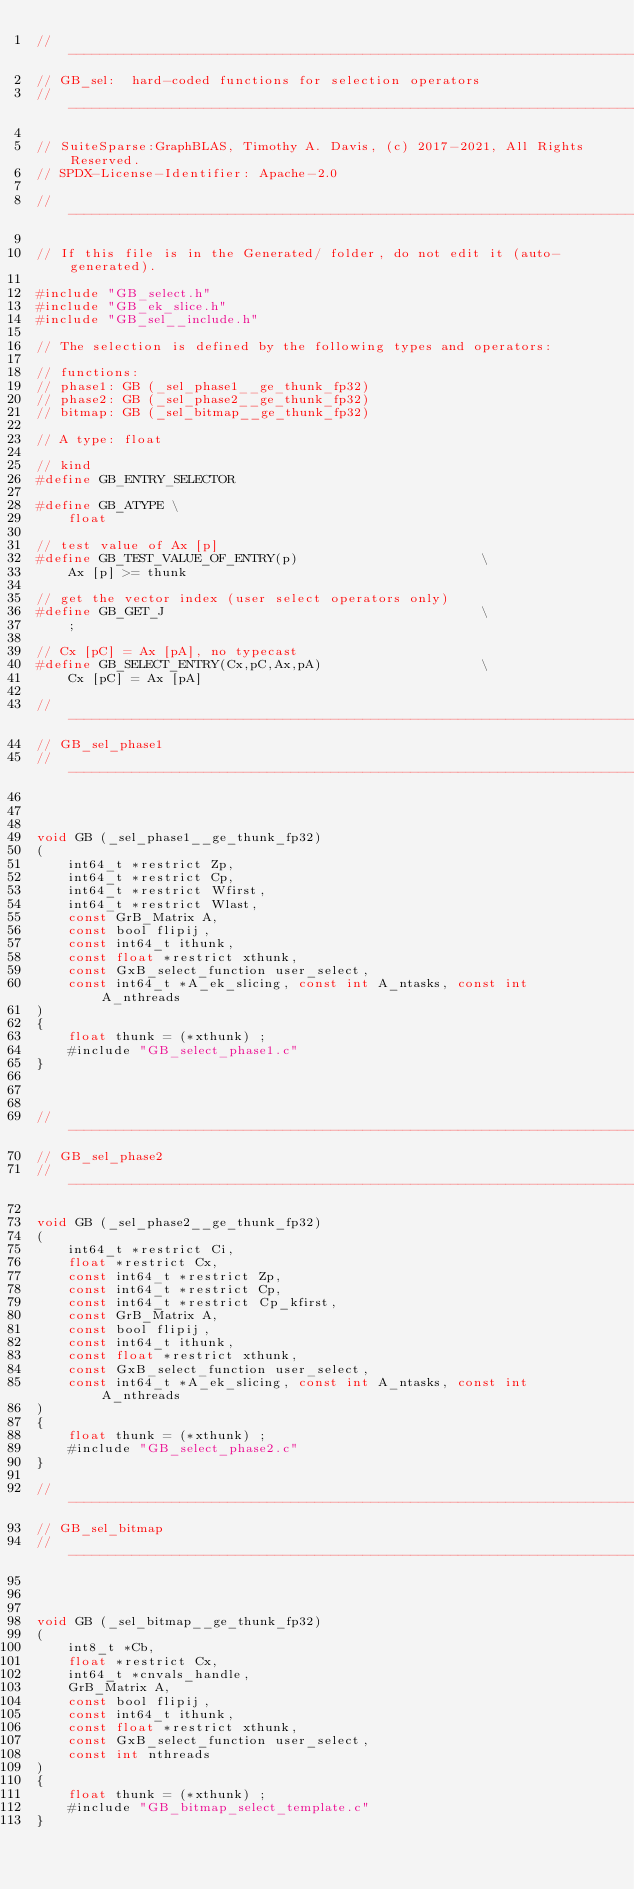Convert code to text. <code><loc_0><loc_0><loc_500><loc_500><_C_>//------------------------------------------------------------------------------
// GB_sel:  hard-coded functions for selection operators
//------------------------------------------------------------------------------

// SuiteSparse:GraphBLAS, Timothy A. Davis, (c) 2017-2021, All Rights Reserved.
// SPDX-License-Identifier: Apache-2.0

//------------------------------------------------------------------------------

// If this file is in the Generated/ folder, do not edit it (auto-generated).

#include "GB_select.h"
#include "GB_ek_slice.h"
#include "GB_sel__include.h"

// The selection is defined by the following types and operators:

// functions:
// phase1: GB (_sel_phase1__ge_thunk_fp32)
// phase2: GB (_sel_phase2__ge_thunk_fp32)
// bitmap: GB (_sel_bitmap__ge_thunk_fp32)

// A type: float

// kind
#define GB_ENTRY_SELECTOR

#define GB_ATYPE \
    float

// test value of Ax [p]
#define GB_TEST_VALUE_OF_ENTRY(p)                       \
    Ax [p] >= thunk

// get the vector index (user select operators only)
#define GB_GET_J                                        \
    ;

// Cx [pC] = Ax [pA], no typecast
#define GB_SELECT_ENTRY(Cx,pC,Ax,pA)                    \
    Cx [pC] = Ax [pA]

//------------------------------------------------------------------------------
// GB_sel_phase1
//------------------------------------------------------------------------------



void GB (_sel_phase1__ge_thunk_fp32)
(
    int64_t *restrict Zp,
    int64_t *restrict Cp,
    int64_t *restrict Wfirst,
    int64_t *restrict Wlast,
    const GrB_Matrix A,
    const bool flipij,
    const int64_t ithunk,
    const float *restrict xthunk,
    const GxB_select_function user_select,
    const int64_t *A_ek_slicing, const int A_ntasks, const int A_nthreads
)
{ 
    float thunk = (*xthunk) ;
    #include "GB_select_phase1.c"
}



//------------------------------------------------------------------------------
// GB_sel_phase2
//------------------------------------------------------------------------------

void GB (_sel_phase2__ge_thunk_fp32)
(
    int64_t *restrict Ci,
    float *restrict Cx,
    const int64_t *restrict Zp,
    const int64_t *restrict Cp,
    const int64_t *restrict Cp_kfirst,
    const GrB_Matrix A,
    const bool flipij,
    const int64_t ithunk,
    const float *restrict xthunk,
    const GxB_select_function user_select,
    const int64_t *A_ek_slicing, const int A_ntasks, const int A_nthreads
)
{ 
    float thunk = (*xthunk) ;
    #include "GB_select_phase2.c"
}

//------------------------------------------------------------------------------
// GB_sel_bitmap
//------------------------------------------------------------------------------



void GB (_sel_bitmap__ge_thunk_fp32)
(
    int8_t *Cb,
    float *restrict Cx,
    int64_t *cnvals_handle,
    GrB_Matrix A,
    const bool flipij,
    const int64_t ithunk,
    const float *restrict xthunk,
    const GxB_select_function user_select,
    const int nthreads
)
{ 
    float thunk = (*xthunk) ;
    #include "GB_bitmap_select_template.c"
}


</code> 